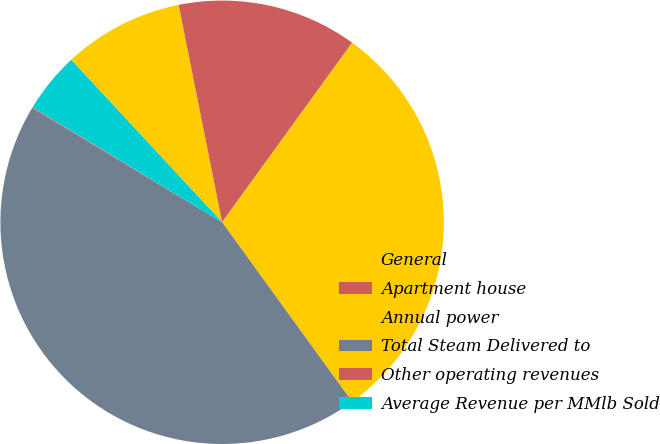<chart> <loc_0><loc_0><loc_500><loc_500><pie_chart><fcel>General<fcel>Apartment house<fcel>Annual power<fcel>Total Steam Delivered to<fcel>Other operating revenues<fcel>Average Revenue per MMlb Sold<nl><fcel>8.77%<fcel>13.12%<fcel>30.05%<fcel>43.6%<fcel>0.06%<fcel>4.41%<nl></chart> 